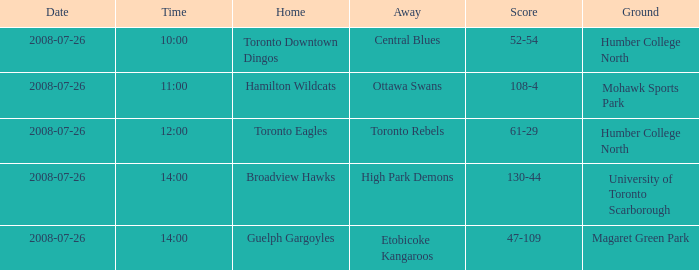With the Ground of Humber College North at 12:00, what was the Away? Toronto Rebels. 